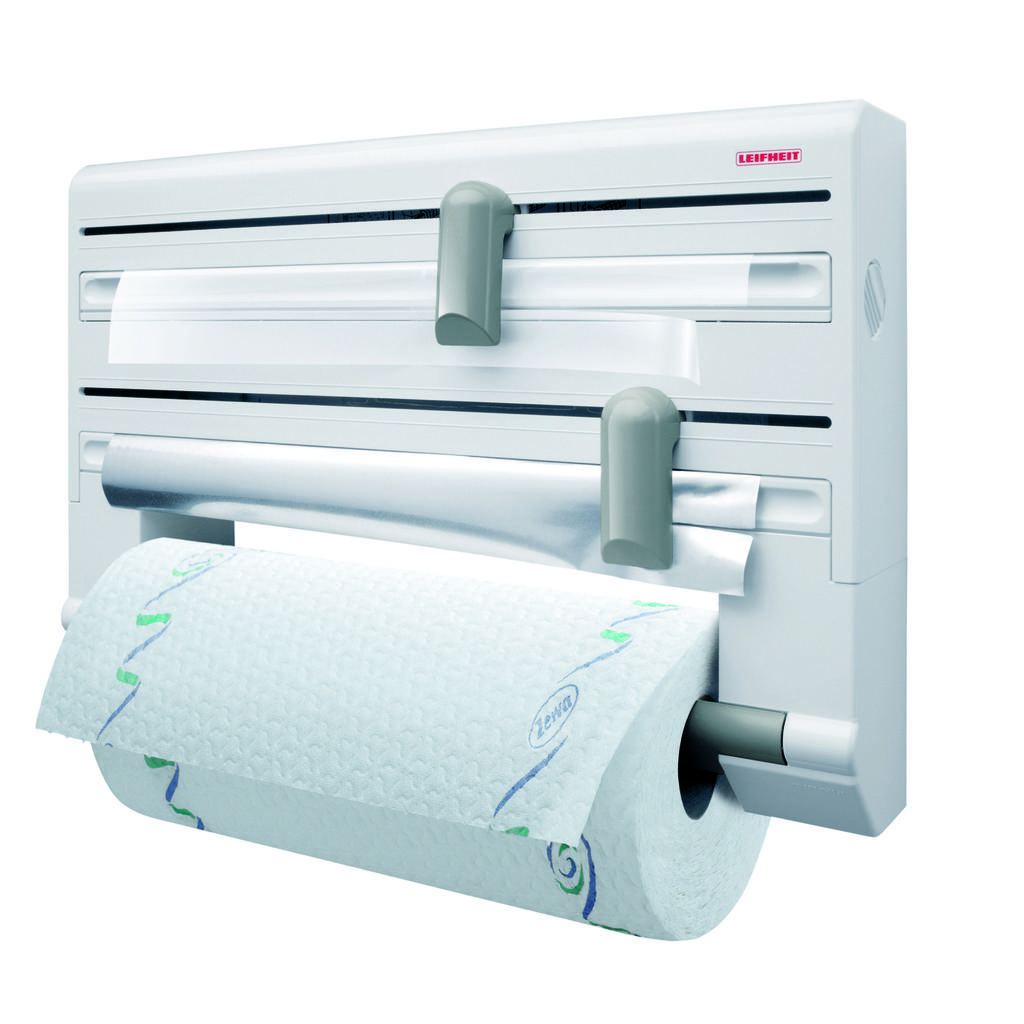Describe this image in one or two sentences. In this image there is a paper towel dispenser. 